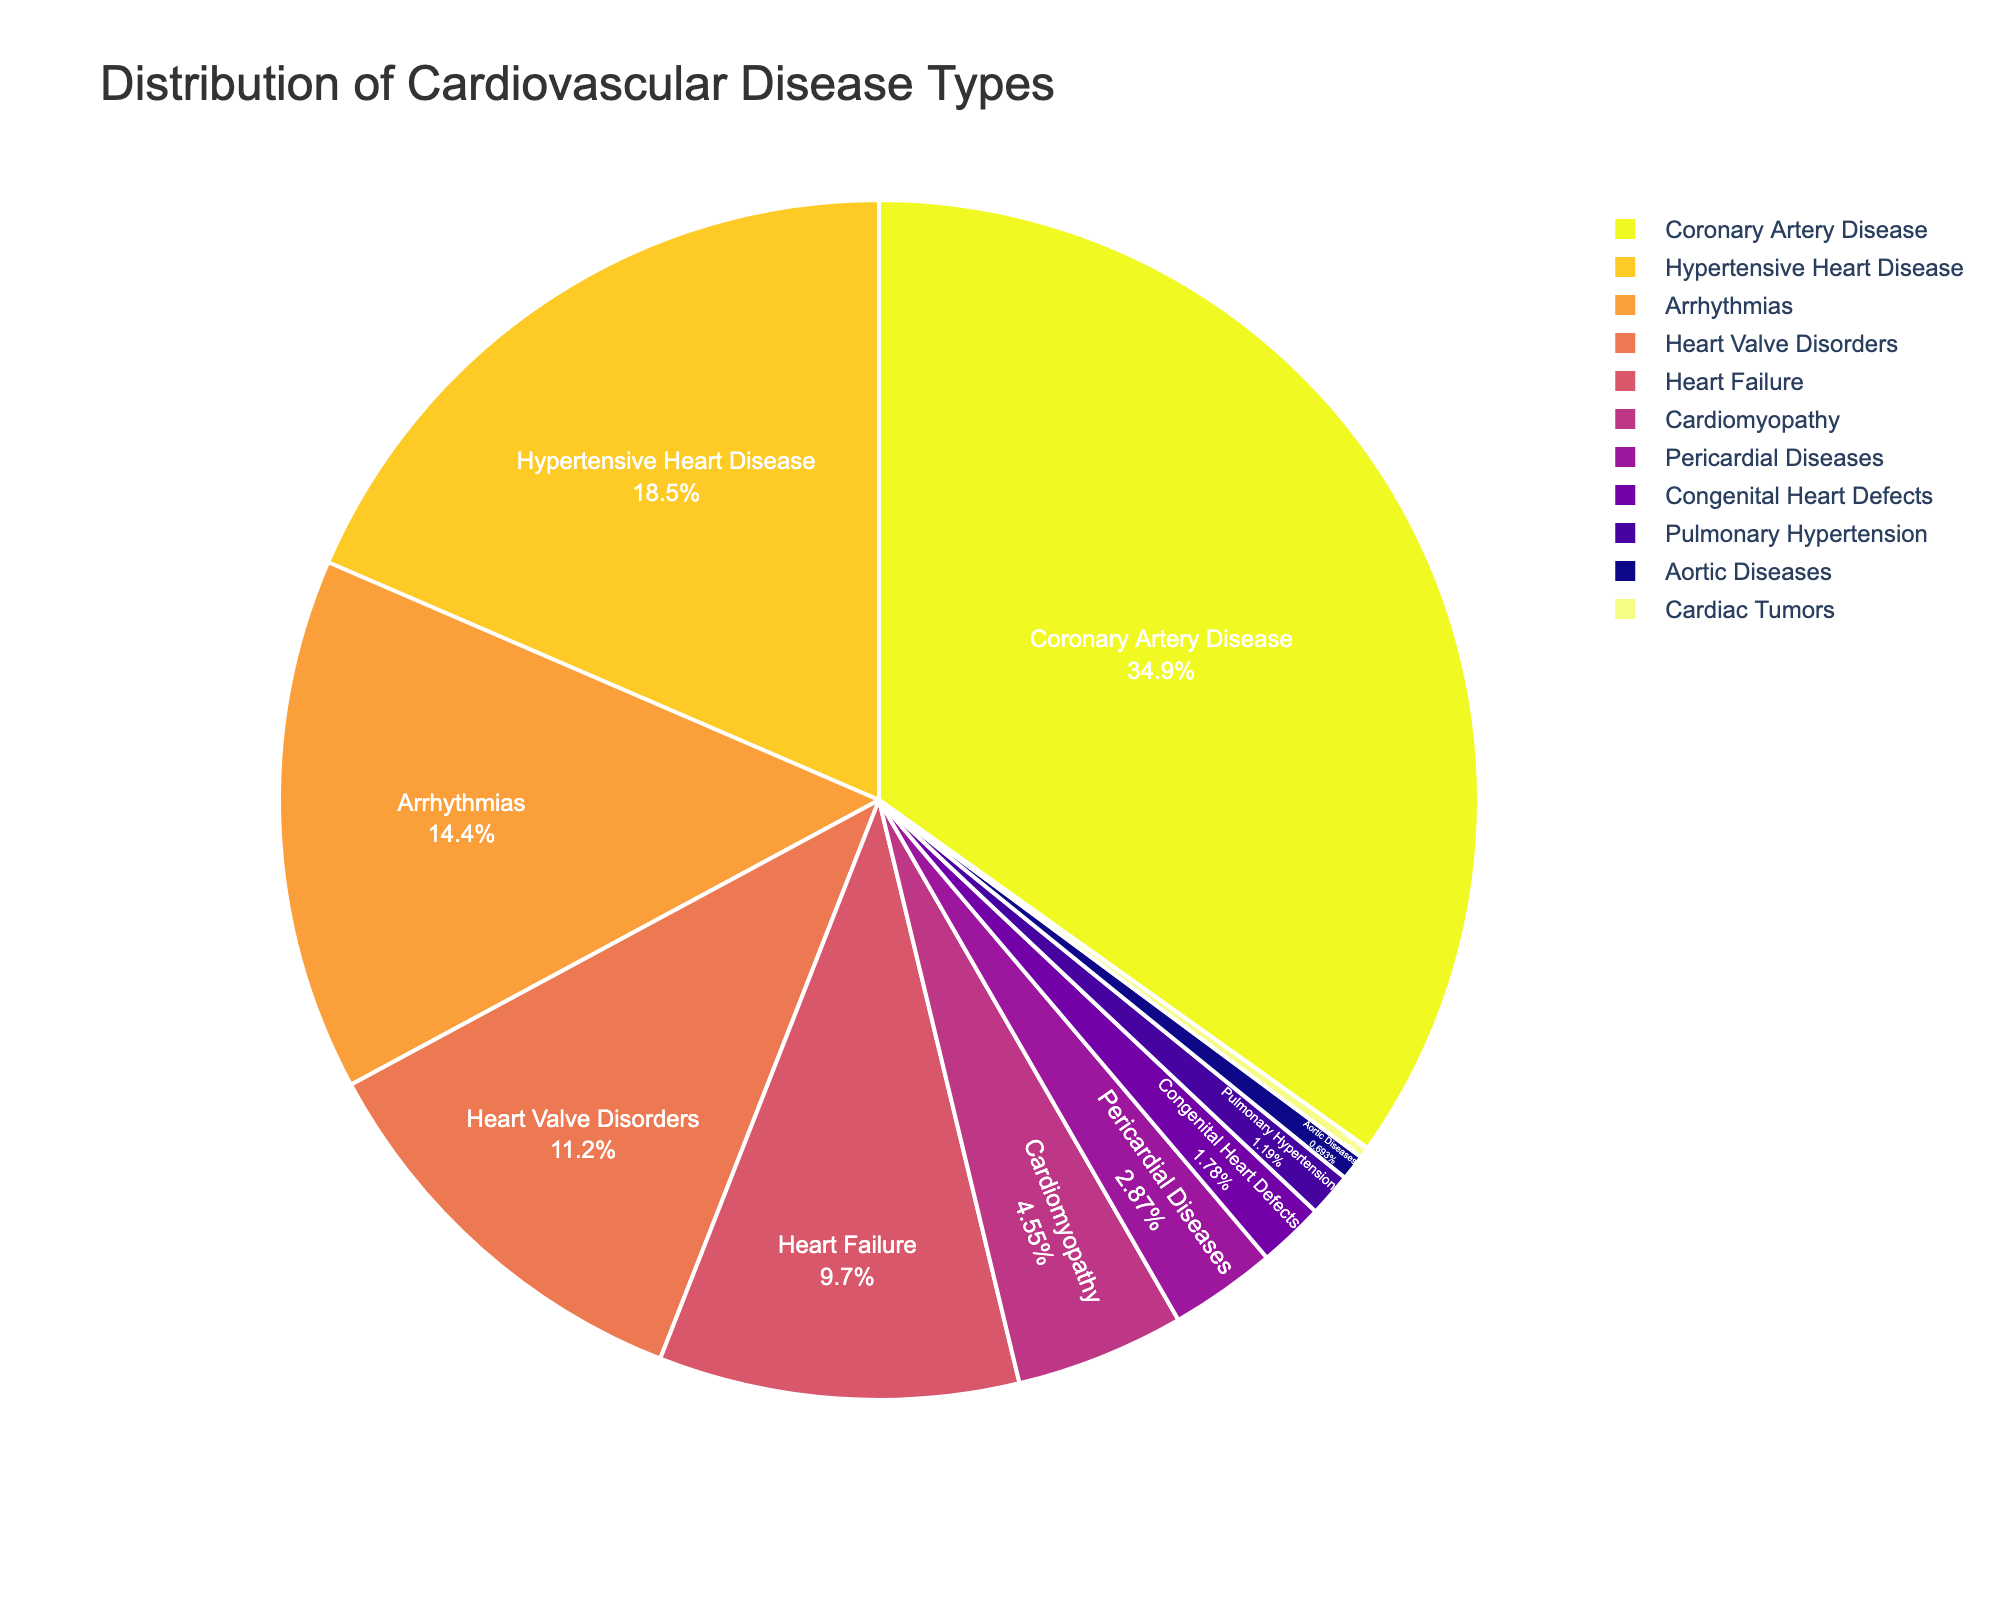Which cardiovascular disease type is most prevalent among patients in the cardiology clinic? The pie chart shows the proportion of each disease. The largest segment, visually identified, corresponds to Coronary Artery Disease at 35.2%.
Answer: Coronary Artery Disease Which two cardiovascular disease types combined have a larger percentage than Coronary Artery Disease alone? Coronary Artery Disease accounts for 35.2%. Hypertensive Heart Disease (18.7%) and Arrhythmias (14.5%) together sum to 33.2%, which is less. Adding Heart Valve Disorders (11.3%) to Hypertensive Heart Disease, we get 30.0%. Therefore, Hypertensive Heart Disease and Heart Valve Disorders combined (18.7% + 11.3% = 30%) do not exceed 35.2%, so we need to include another type.
Answer: Hypertensive Heart Disease, Arrhythmias, and Heart Valve Disorders How does the prevalence of Heart Failure compare to Cardiomyopathy? The pie chart segments reveal percentages for each disease: Heart Failure is 9.8%, while Cardiomyopathy is 4.6%. Heart Failure has a larger percentage.
Answer: Heart Failure is more prevalent What is the combined percentage of diseases accounting for less than 5% each? Summing the percentages for Cardiomyopathy (4.6%), Pericardial Diseases (2.9%), Congenital Heart Defects (1.8%), Pulmonary Hypertension (1.2%), Aortic Diseases (0.7%), and Cardiac Tumors (0.3%) gives: 4.6% + 2.9% + 1.8% + 1.2% + 0.7% + 0.3% = 11.5%.
Answer: 11.5% What color represents Hypertensive Heart Disease in the pie chart? Look for the labeled segment corresponding to Hypertensive Heart Disease and identify the associated color. It is second in size and typically colored with a sequential color in the given palette. The specific color can be observed directly in the pie chart.
Answer: (This answer would require viewing the actual pie chart to identify the exact color.) Is the percentage of Arrhythmias higher than that of Heart Valve Disorders? Comparing the two segments, Arrhythmias is at 14.5% and Heart Valve Disorders at 11.3%. Visually, the segment for Arrhythmias is larger than that for Heart Valve Disorders.
Answer: Yes What proportion of patients have either Coronary Artery Disease or Hypertensive Heart Disease? Summing the percentages of these two disease types: Coronary Artery Disease (35.2%) + Hypertensive Heart Disease (18.7%) = 53.9%.
Answer: 53.9% How many disease types have a percentage greater than 10%? Identify all disease types with segments larger than 10% by observing their labeled percentages. These are Coronary Artery Disease (35.2%), Hypertensive Heart Disease (18.7%), and Arrhythmias (14.5%), and Heart Valve Disorders (11.3%).
Answer: Four What is the combined percentage of Heart Valve Disorders and Heart Failure? Add the percentages of Heart Valve Disorders (11.3%) and Heart Failure (9.8%) to get: 11.3% + 9.8% = 21.1%.
Answer: 21.1% How does the size of the pie segment for Pulmonary Hypertension compare to that for Pericardial Diseases? Visually compare the relative sizes of the Pulmonary Hypertension (1.2%) and Pericardial Diseases (2.9%) segments. Pulmonary Hypertension is smaller.
Answer: Pericardial Diseases is larger 